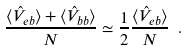Convert formula to latex. <formula><loc_0><loc_0><loc_500><loc_500>\frac { \langle \hat { V } _ { e b } \rangle + \langle \hat { V } _ { b b } \rangle } { N } \simeq \frac { 1 } { 2 } \frac { \langle \hat { V } _ { e b } \rangle } { N } \ .</formula> 